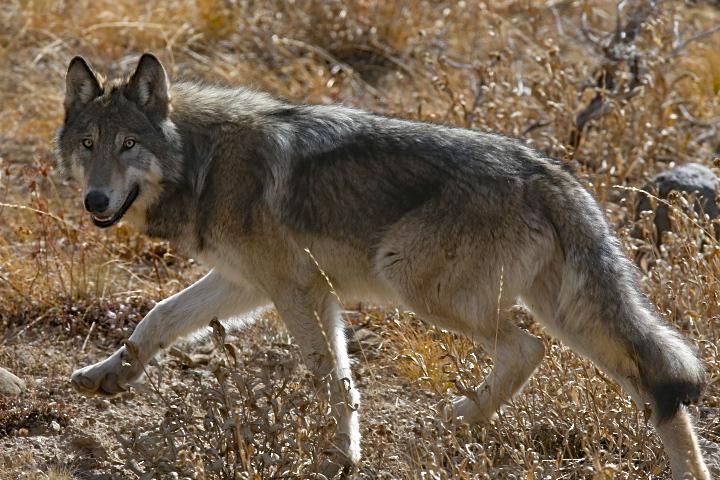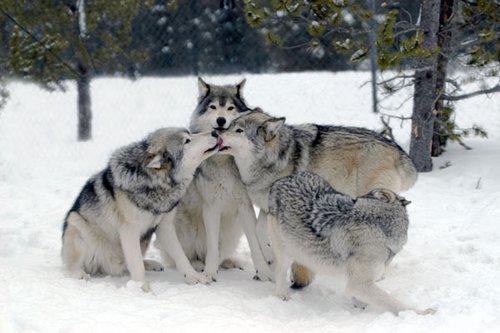The first image is the image on the left, the second image is the image on the right. Considering the images on both sides, is "The wolves are in a group in at least one picture." valid? Answer yes or no. Yes. The first image is the image on the left, the second image is the image on the right. For the images shown, is this caption "Each image contains exactly one wolf, and one image features a wolf that is standing still and looking toward the camera." true? Answer yes or no. No. 